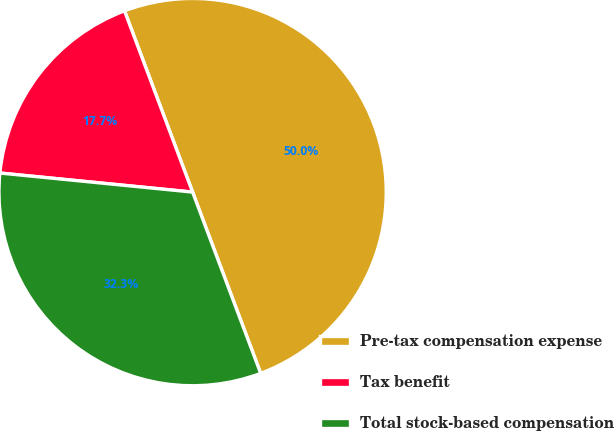Convert chart. <chart><loc_0><loc_0><loc_500><loc_500><pie_chart><fcel>Pre-tax compensation expense<fcel>Tax benefit<fcel>Total stock-based compensation<nl><fcel>50.0%<fcel>17.71%<fcel>32.29%<nl></chart> 